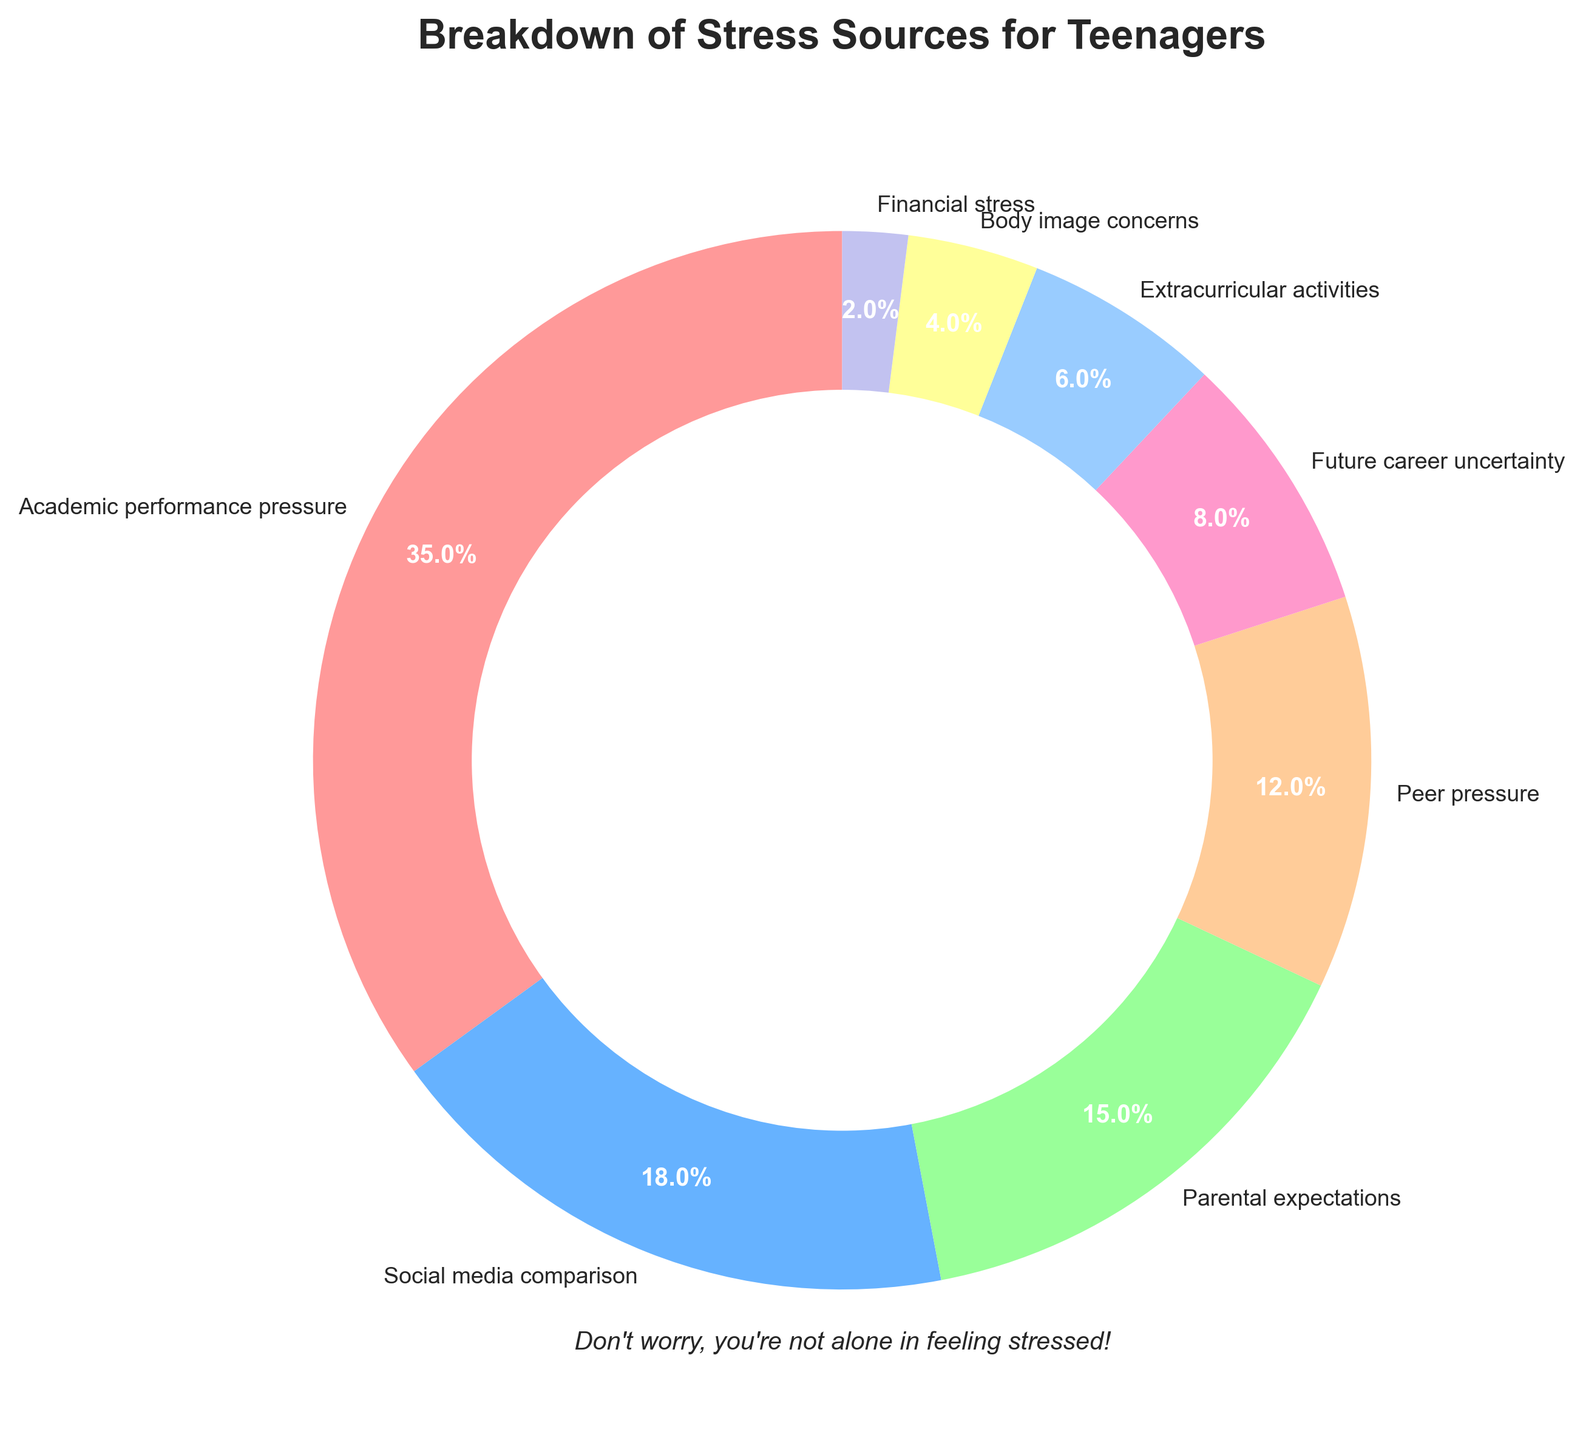What's the largest source of stress for teenagers? The pie chart shows that "Academic performance pressure" is the largest source of stress, occupying the biggest segment.
Answer: Academic performance pressure Which source of stress has a percentage more than twice that of "Future career uncertainty"? "Future career uncertainty" is 8%. The segment with more than twice this value (i.e., more than 16%) is "Academic performance pressure" at 35% and "Social media comparison" at 18%.
Answer: Academic performance pressure and Social media comparison How much more does "Parental expectations" contribute to stress compared to "Extracurricular activities"? "Parental expectations" accounts for 15% and "Extracurricular activities" accounts for 6%, so the difference is 15% - 6% = 9%.
Answer: 9% List the sources of stress that have percentages less than or equal to 10%. From the chart, the sources with percentages less than or equal to 10% are "Future career uncertainty" (8%), "Extracurricular activities" (6%), "Body image concerns" (4%), and "Financial stress" (2%).
Answer: Future career uncertainty, Extracurricular activities, Body image concerns, Financial stress What is the combined percentage of stress sources related to social factors ("Social media comparison", "Peer pressure", and "Body image concerns")? Adding their percentages: "Social media comparison" (18%) + "Peer pressure" (12%) + "Body image concerns" (4%) = 18% + 12% + 4% = 34%.
Answer: 34% Which source of stress is represented by the light blue color in the pie chart? By visually matching the color, the light blue segment corresponds to "Extracurricular activities."
Answer: Extracurricular activities Compare the stress from the least and most significant sources. How many times more significant is the most considerable source? The least significant source is "Financial stress" at 2%, and the most significant is "Academic performance pressure" at 35%. To find how many times more significant: 35% / 2% = 17.5.
Answer: 17.5 What is the second largest source of stress after "Academic performance pressure"? The next biggest segment after "Academic performance pressure" (35%) is "Social media comparison" at 18%.
Answer: Social media comparison What's the total percentage of stress sources that are related to future uncertainties ("Future career uncertainty" and "Financial stress")? Adding their percentages: "Future career uncertainty" (8%) + "Financial stress" (2%) = 8% + 2% = 10%.
Answer: 10% 